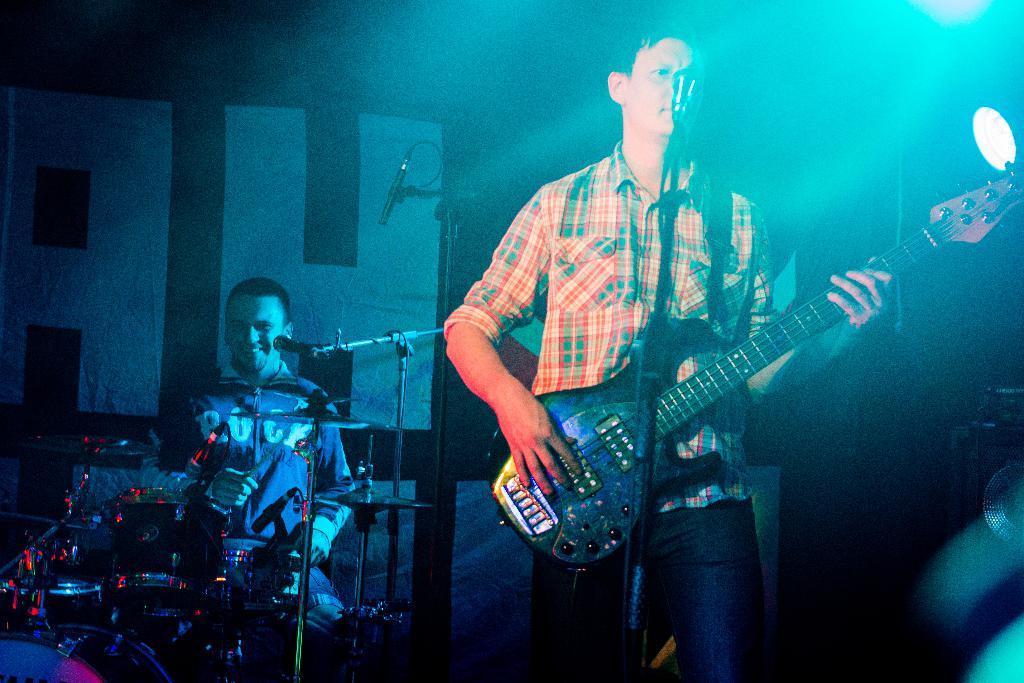How would you summarize this image in a sentence or two? In this image I can see there is a man standing and he is playing guitar, there is a microphone attached to the stand. There is a person playing drum set in the background, there are few lights attached to the ceiling. 